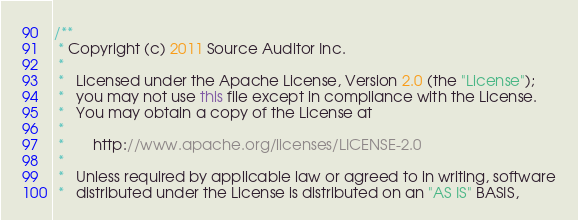Convert code to text. <code><loc_0><loc_0><loc_500><loc_500><_Java_>/**
 * Copyright (c) 2011 Source Auditor Inc.
 *
 *   Licensed under the Apache License, Version 2.0 (the "License");
 *   you may not use this file except in compliance with the License.
 *   You may obtain a copy of the License at
 *
 *       http://www.apache.org/licenses/LICENSE-2.0
 *
 *   Unless required by applicable law or agreed to in writing, software
 *   distributed under the License is distributed on an "AS IS" BASIS,</code> 